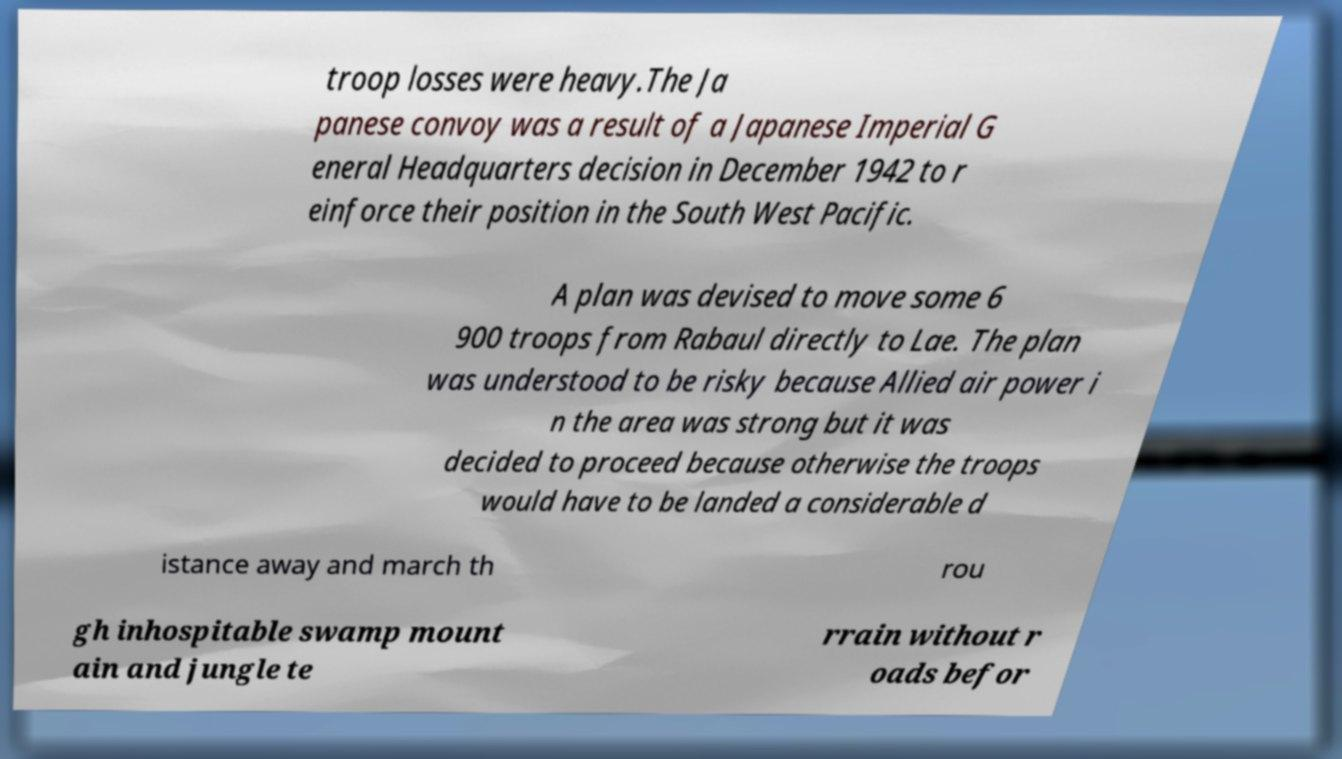There's text embedded in this image that I need extracted. Can you transcribe it verbatim? troop losses were heavy.The Ja panese convoy was a result of a Japanese Imperial G eneral Headquarters decision in December 1942 to r einforce their position in the South West Pacific. A plan was devised to move some 6 900 troops from Rabaul directly to Lae. The plan was understood to be risky because Allied air power i n the area was strong but it was decided to proceed because otherwise the troops would have to be landed a considerable d istance away and march th rou gh inhospitable swamp mount ain and jungle te rrain without r oads befor 